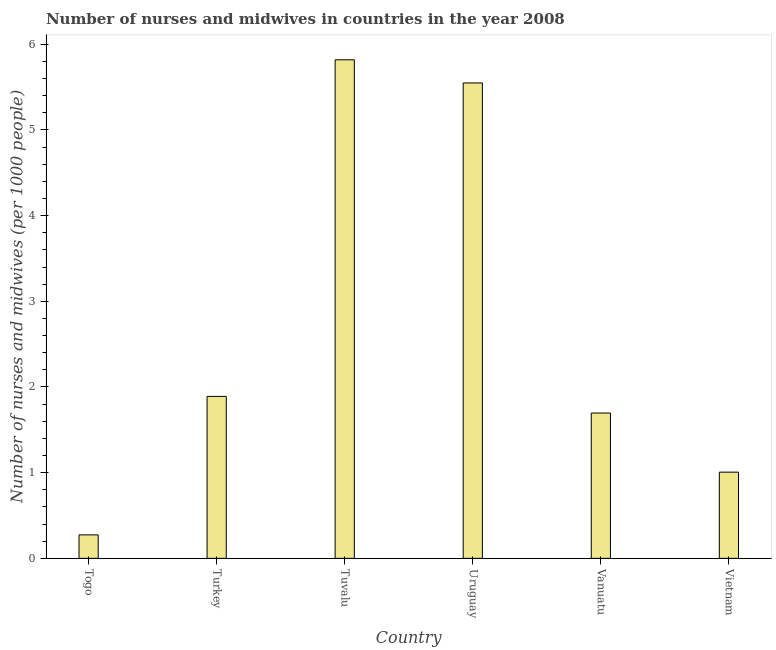What is the title of the graph?
Make the answer very short. Number of nurses and midwives in countries in the year 2008. What is the label or title of the X-axis?
Make the answer very short. Country. What is the label or title of the Y-axis?
Keep it short and to the point. Number of nurses and midwives (per 1000 people). What is the number of nurses and midwives in Togo?
Give a very brief answer. 0.27. Across all countries, what is the maximum number of nurses and midwives?
Your response must be concise. 5.82. Across all countries, what is the minimum number of nurses and midwives?
Offer a very short reply. 0.27. In which country was the number of nurses and midwives maximum?
Give a very brief answer. Tuvalu. In which country was the number of nurses and midwives minimum?
Offer a very short reply. Togo. What is the sum of the number of nurses and midwives?
Give a very brief answer. 16.23. What is the difference between the number of nurses and midwives in Turkey and Vanuatu?
Offer a very short reply. 0.19. What is the average number of nurses and midwives per country?
Offer a very short reply. 2.71. What is the median number of nurses and midwives?
Make the answer very short. 1.79. In how many countries, is the number of nurses and midwives greater than 2 ?
Offer a terse response. 2. What is the ratio of the number of nurses and midwives in Tuvalu to that in Vietnam?
Provide a succinct answer. 5.78. Is the difference between the number of nurses and midwives in Vanuatu and Vietnam greater than the difference between any two countries?
Offer a terse response. No. What is the difference between the highest and the second highest number of nurses and midwives?
Ensure brevity in your answer.  0.27. Is the sum of the number of nurses and midwives in Tuvalu and Uruguay greater than the maximum number of nurses and midwives across all countries?
Your answer should be very brief. Yes. What is the difference between the highest and the lowest number of nurses and midwives?
Make the answer very short. 5.54. Are all the bars in the graph horizontal?
Keep it short and to the point. No. How many countries are there in the graph?
Your answer should be very brief. 6. What is the difference between two consecutive major ticks on the Y-axis?
Your response must be concise. 1. What is the Number of nurses and midwives (per 1000 people) in Togo?
Make the answer very short. 0.27. What is the Number of nurses and midwives (per 1000 people) in Turkey?
Give a very brief answer. 1.89. What is the Number of nurses and midwives (per 1000 people) of Tuvalu?
Offer a terse response. 5.82. What is the Number of nurses and midwives (per 1000 people) of Uruguay?
Keep it short and to the point. 5.55. What is the Number of nurses and midwives (per 1000 people) of Vanuatu?
Provide a succinct answer. 1.7. What is the difference between the Number of nurses and midwives (per 1000 people) in Togo and Turkey?
Keep it short and to the point. -1.62. What is the difference between the Number of nurses and midwives (per 1000 people) in Togo and Tuvalu?
Ensure brevity in your answer.  -5.54. What is the difference between the Number of nurses and midwives (per 1000 people) in Togo and Uruguay?
Keep it short and to the point. -5.27. What is the difference between the Number of nurses and midwives (per 1000 people) in Togo and Vanuatu?
Your response must be concise. -1.42. What is the difference between the Number of nurses and midwives (per 1000 people) in Togo and Vietnam?
Provide a succinct answer. -0.73. What is the difference between the Number of nurses and midwives (per 1000 people) in Turkey and Tuvalu?
Keep it short and to the point. -3.93. What is the difference between the Number of nurses and midwives (per 1000 people) in Turkey and Uruguay?
Provide a succinct answer. -3.66. What is the difference between the Number of nurses and midwives (per 1000 people) in Turkey and Vanuatu?
Provide a short and direct response. 0.19. What is the difference between the Number of nurses and midwives (per 1000 people) in Turkey and Vietnam?
Give a very brief answer. 0.88. What is the difference between the Number of nurses and midwives (per 1000 people) in Tuvalu and Uruguay?
Offer a very short reply. 0.27. What is the difference between the Number of nurses and midwives (per 1000 people) in Tuvalu and Vanuatu?
Provide a succinct answer. 4.12. What is the difference between the Number of nurses and midwives (per 1000 people) in Tuvalu and Vietnam?
Provide a succinct answer. 4.81. What is the difference between the Number of nurses and midwives (per 1000 people) in Uruguay and Vanuatu?
Provide a succinct answer. 3.85. What is the difference between the Number of nurses and midwives (per 1000 people) in Uruguay and Vietnam?
Offer a terse response. 4.54. What is the difference between the Number of nurses and midwives (per 1000 people) in Vanuatu and Vietnam?
Make the answer very short. 0.69. What is the ratio of the Number of nurses and midwives (per 1000 people) in Togo to that in Turkey?
Offer a very short reply. 0.14. What is the ratio of the Number of nurses and midwives (per 1000 people) in Togo to that in Tuvalu?
Provide a succinct answer. 0.05. What is the ratio of the Number of nurses and midwives (per 1000 people) in Togo to that in Uruguay?
Offer a very short reply. 0.05. What is the ratio of the Number of nurses and midwives (per 1000 people) in Togo to that in Vanuatu?
Provide a short and direct response. 0.16. What is the ratio of the Number of nurses and midwives (per 1000 people) in Togo to that in Vietnam?
Your response must be concise. 0.27. What is the ratio of the Number of nurses and midwives (per 1000 people) in Turkey to that in Tuvalu?
Your answer should be compact. 0.33. What is the ratio of the Number of nurses and midwives (per 1000 people) in Turkey to that in Uruguay?
Your answer should be very brief. 0.34. What is the ratio of the Number of nurses and midwives (per 1000 people) in Turkey to that in Vanuatu?
Your answer should be very brief. 1.11. What is the ratio of the Number of nurses and midwives (per 1000 people) in Turkey to that in Vietnam?
Make the answer very short. 1.88. What is the ratio of the Number of nurses and midwives (per 1000 people) in Tuvalu to that in Uruguay?
Offer a very short reply. 1.05. What is the ratio of the Number of nurses and midwives (per 1000 people) in Tuvalu to that in Vanuatu?
Provide a short and direct response. 3.43. What is the ratio of the Number of nurses and midwives (per 1000 people) in Tuvalu to that in Vietnam?
Ensure brevity in your answer.  5.78. What is the ratio of the Number of nurses and midwives (per 1000 people) in Uruguay to that in Vanuatu?
Give a very brief answer. 3.27. What is the ratio of the Number of nurses and midwives (per 1000 people) in Uruguay to that in Vietnam?
Provide a short and direct response. 5.51. What is the ratio of the Number of nurses and midwives (per 1000 people) in Vanuatu to that in Vietnam?
Give a very brief answer. 1.69. 